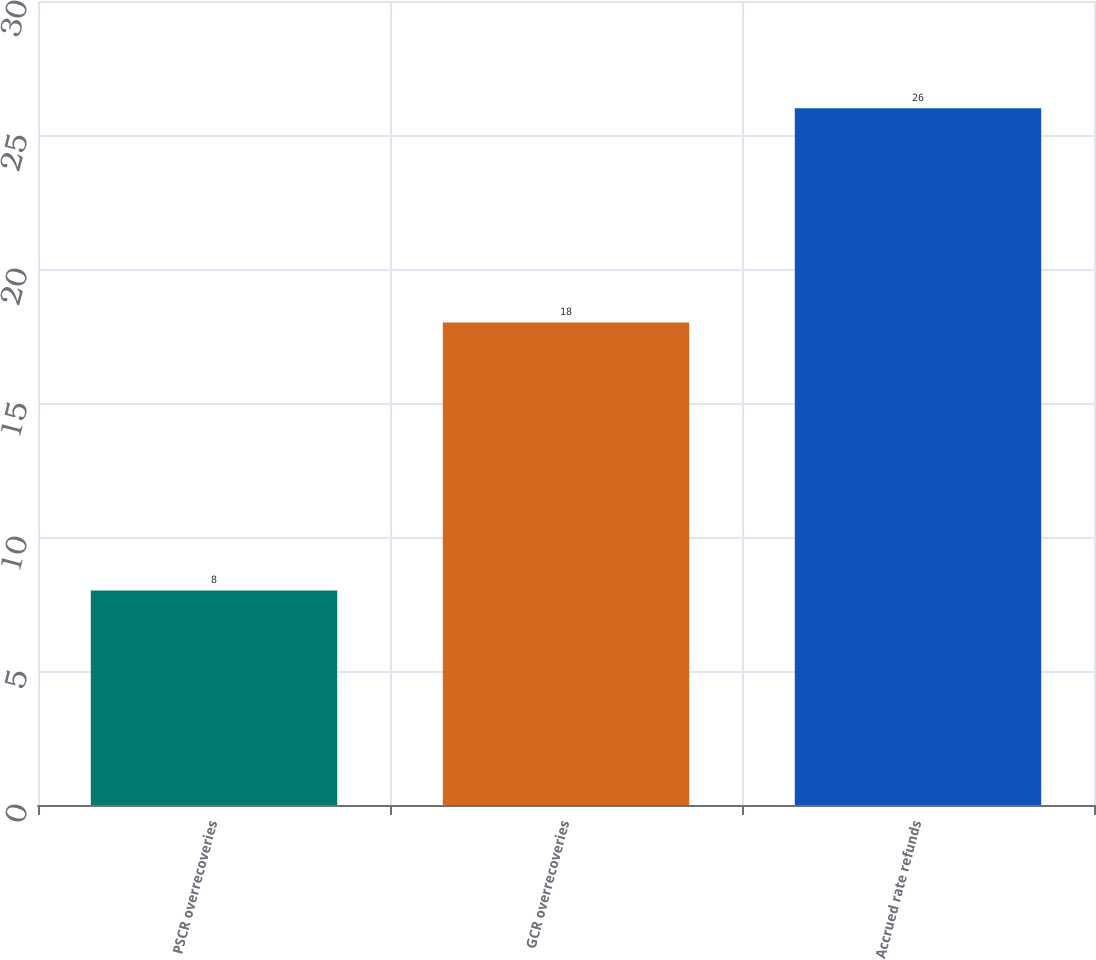Convert chart. <chart><loc_0><loc_0><loc_500><loc_500><bar_chart><fcel>PSCR overrecoveries<fcel>GCR overrecoveries<fcel>Accrued rate refunds<nl><fcel>8<fcel>18<fcel>26<nl></chart> 